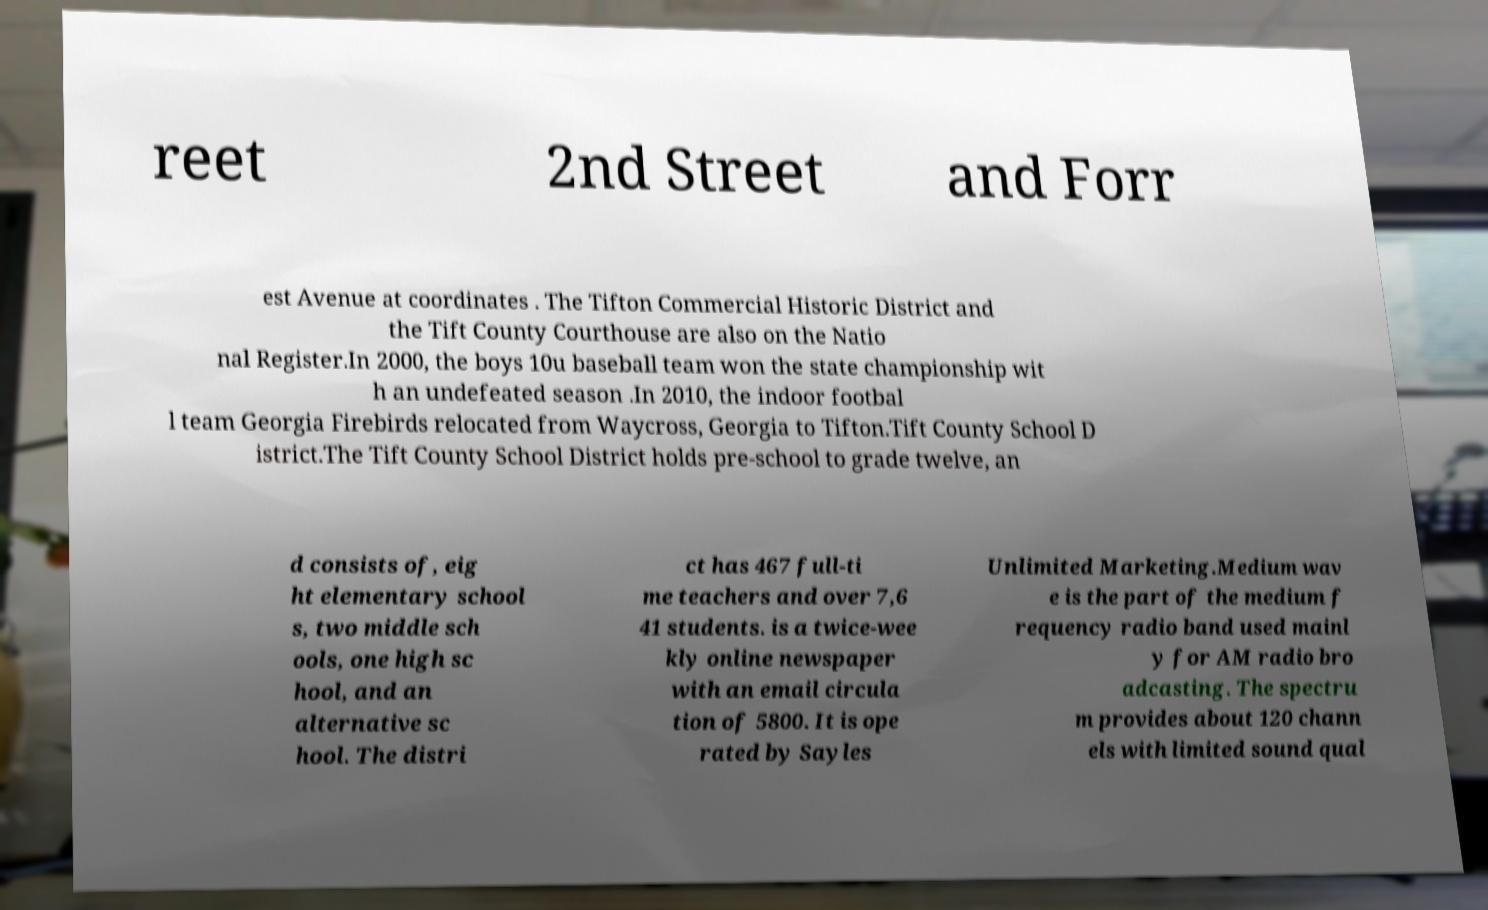Could you extract and type out the text from this image? reet 2nd Street and Forr est Avenue at coordinates . The Tifton Commercial Historic District and the Tift County Courthouse are also on the Natio nal Register.In 2000, the boys 10u baseball team won the state championship wit h an undefeated season .In 2010, the indoor footbal l team Georgia Firebirds relocated from Waycross, Georgia to Tifton.Tift County School D istrict.The Tift County School District holds pre-school to grade twelve, an d consists of, eig ht elementary school s, two middle sch ools, one high sc hool, and an alternative sc hool. The distri ct has 467 full-ti me teachers and over 7,6 41 students. is a twice-wee kly online newspaper with an email circula tion of 5800. It is ope rated by Sayles Unlimited Marketing.Medium wav e is the part of the medium f requency radio band used mainl y for AM radio bro adcasting. The spectru m provides about 120 chann els with limited sound qual 